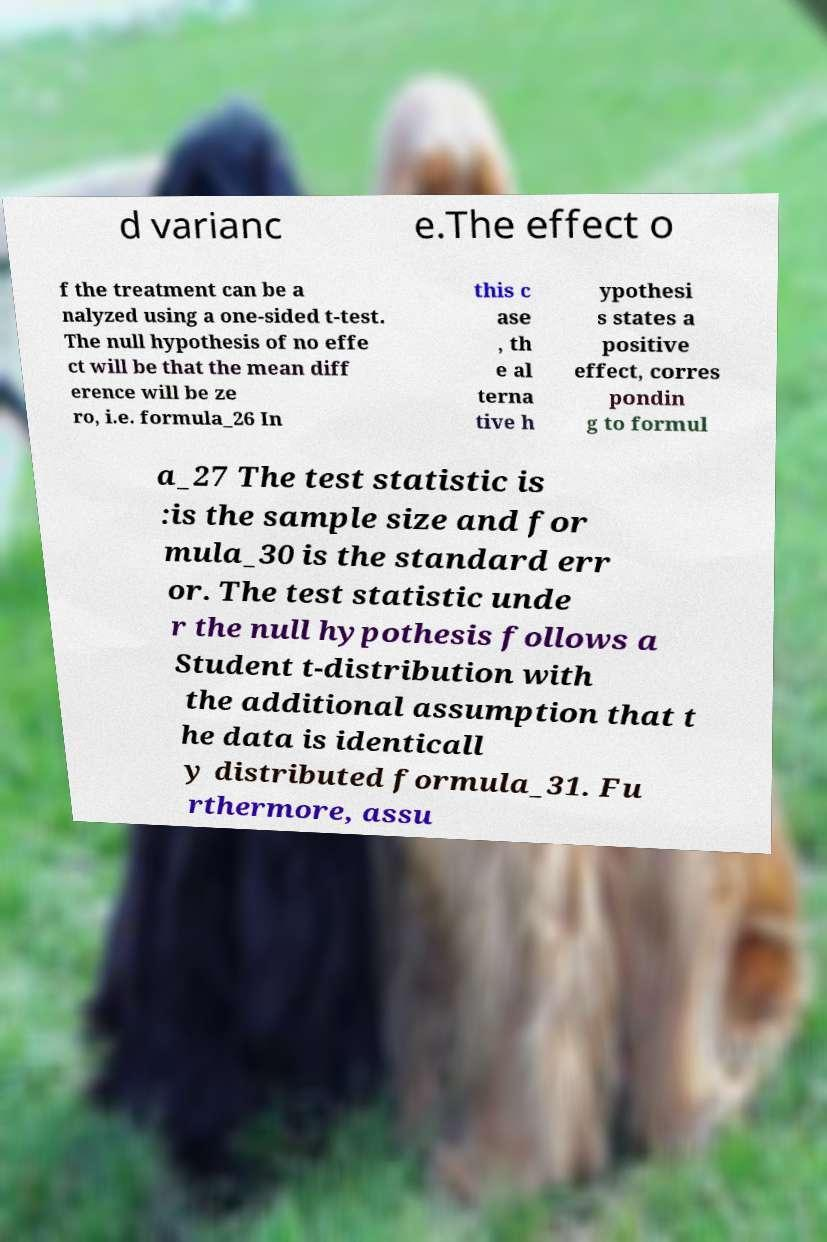Can you accurately transcribe the text from the provided image for me? d varianc e.The effect o f the treatment can be a nalyzed using a one-sided t-test. The null hypothesis of no effe ct will be that the mean diff erence will be ze ro, i.e. formula_26 In this c ase , th e al terna tive h ypothesi s states a positive effect, corres pondin g to formul a_27 The test statistic is :is the sample size and for mula_30 is the standard err or. The test statistic unde r the null hypothesis follows a Student t-distribution with the additional assumption that t he data is identicall y distributed formula_31. Fu rthermore, assu 